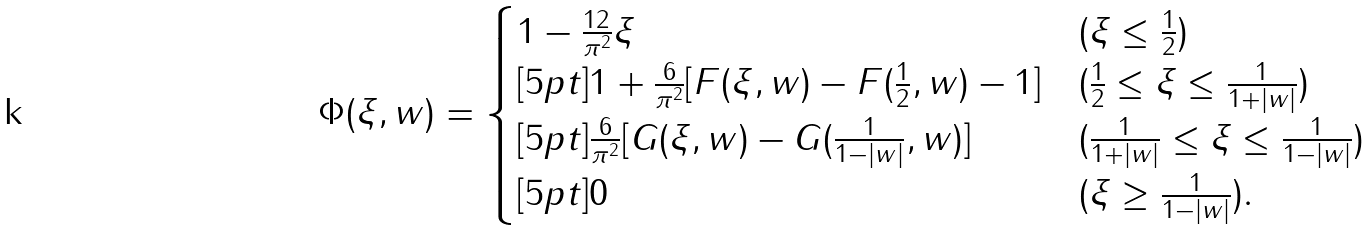Convert formula to latex. <formula><loc_0><loc_0><loc_500><loc_500>\Phi ( \xi , w ) = \begin{cases} 1 - \frac { 1 2 } { \pi ^ { 2 } } \xi & ( \xi \leq \frac { 1 } { 2 } ) \\ [ 5 p t ] 1 + \frac { 6 } { \pi ^ { 2 } } [ F ( \xi , w ) - F ( \frac { 1 } { 2 } , w ) - 1 ] & ( \frac { 1 } { 2 } \leq \xi \leq \frac { 1 } { 1 + | w | } ) \\ [ 5 p t ] \frac { 6 } { \pi ^ { 2 } } [ G ( \xi , w ) - G ( \frac { 1 } { 1 - | w | } , w ) ] & ( \frac { 1 } { 1 + | w | } \leq \xi \leq \frac { 1 } { 1 - | w | } ) \\ [ 5 p t ] 0 & ( \xi \geq \frac { 1 } { 1 - | w | } ) . \end{cases}</formula> 